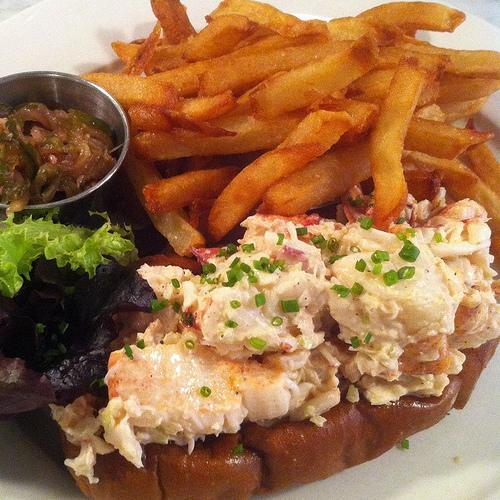Question: what is on top of the sandwich?
Choices:
A. Cheddar cheese.
B. Romaine lettuce.
C. Chives.
D. Fresh tomatoes.
Answer with the letter. Answer: C Question: what is in the dish?
Choices:
A. Zucchini.
B. Carrots.
C. Tomatoes.
D. Onions.
Answer with the letter. Answer: D 